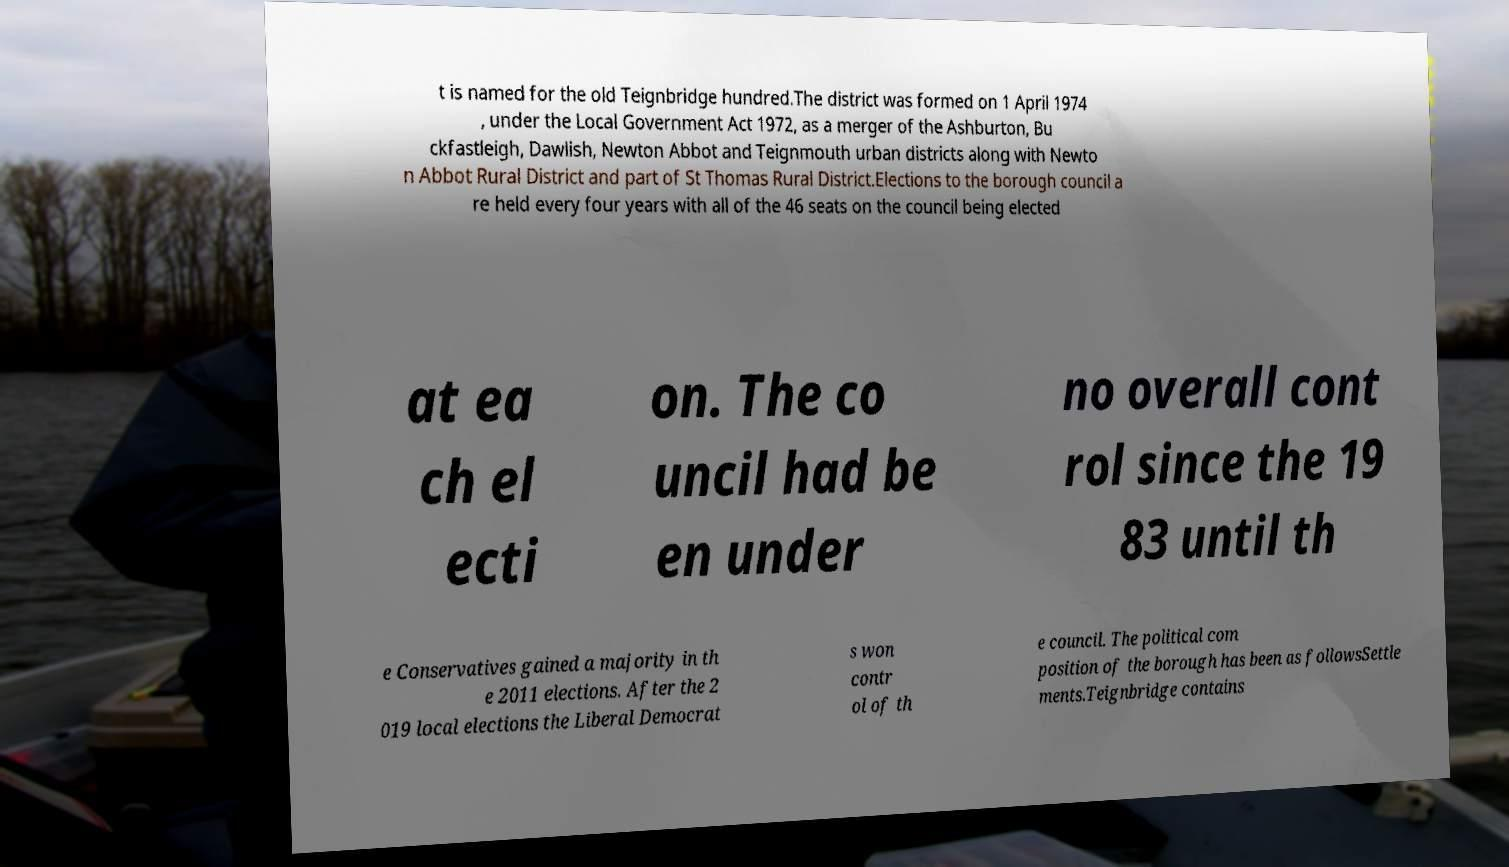What messages or text are displayed in this image? I need them in a readable, typed format. t is named for the old Teignbridge hundred.The district was formed on 1 April 1974 , under the Local Government Act 1972, as a merger of the Ashburton, Bu ckfastleigh, Dawlish, Newton Abbot and Teignmouth urban districts along with Newto n Abbot Rural District and part of St Thomas Rural District.Elections to the borough council a re held every four years with all of the 46 seats on the council being elected at ea ch el ecti on. The co uncil had be en under no overall cont rol since the 19 83 until th e Conservatives gained a majority in th e 2011 elections. After the 2 019 local elections the Liberal Democrat s won contr ol of th e council. The political com position of the borough has been as followsSettle ments.Teignbridge contains 